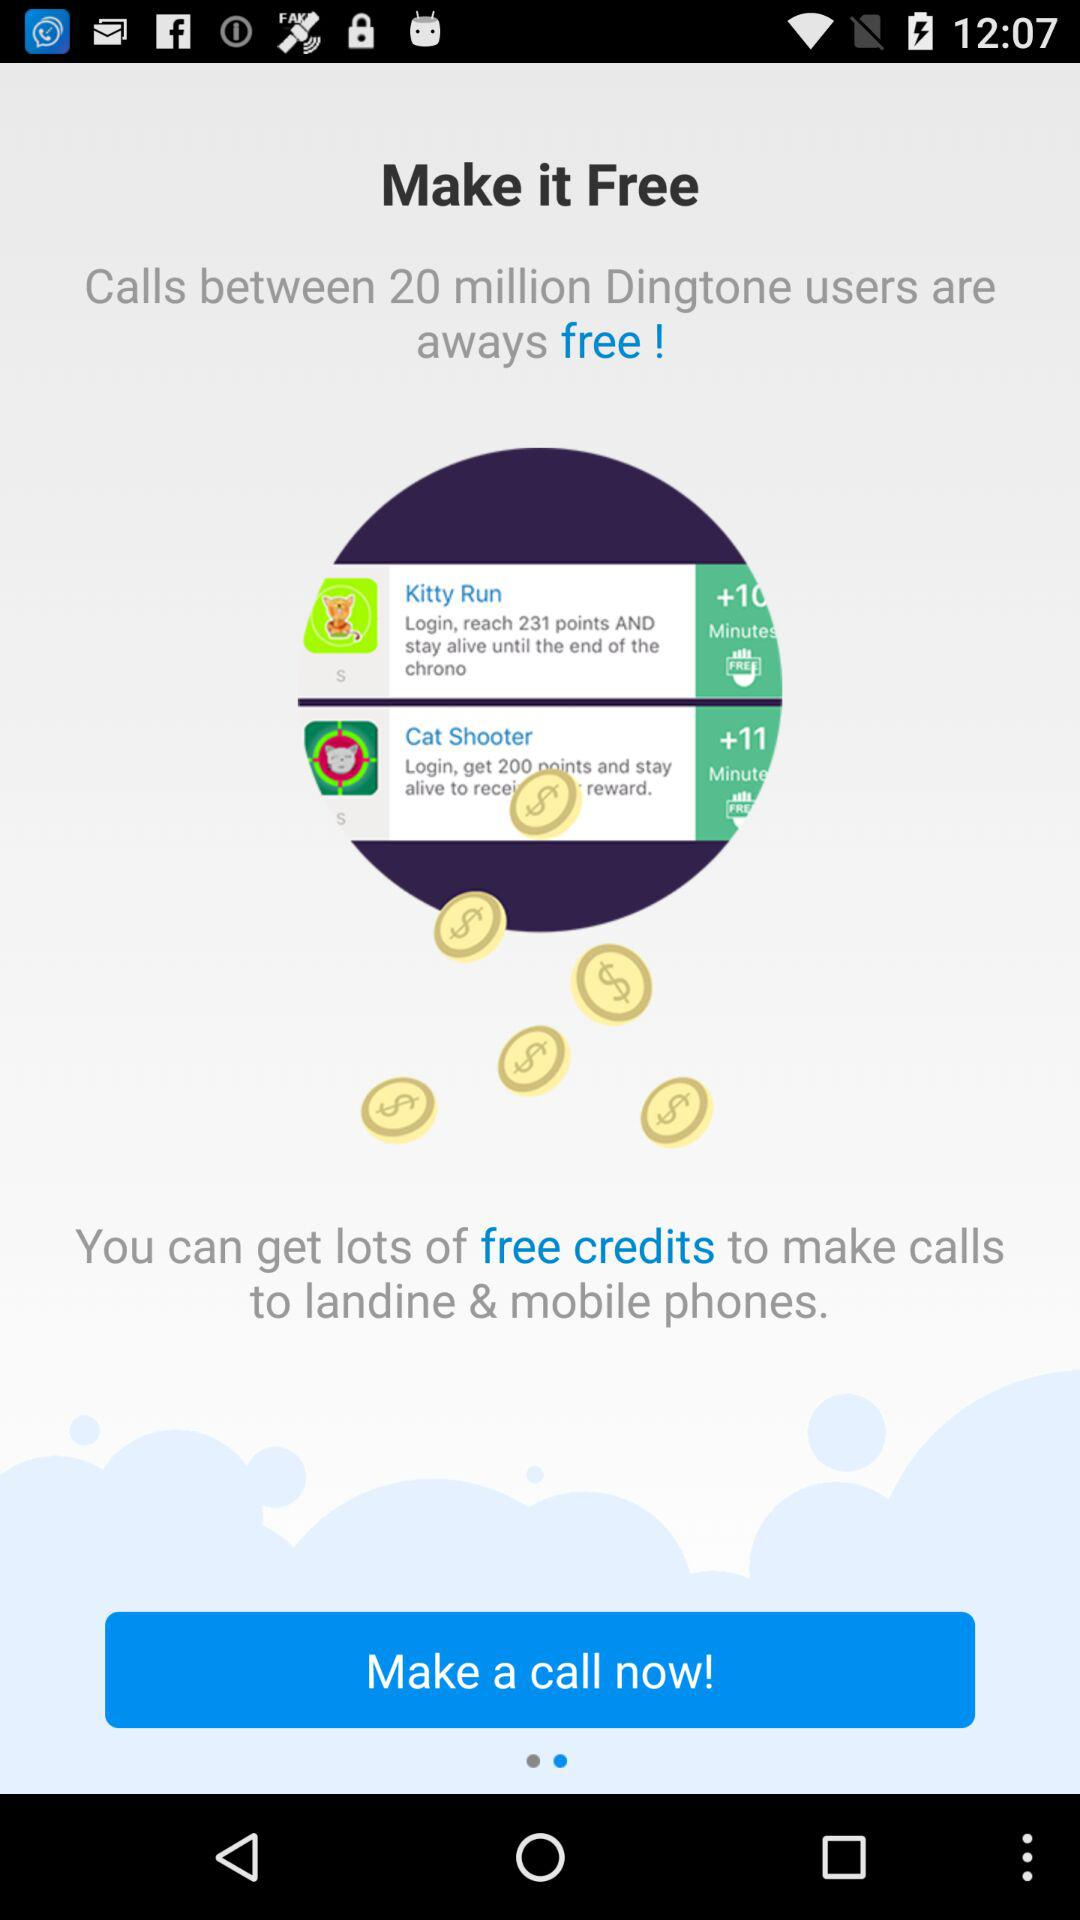Between how many "Dingtone" users are the calls free? The calls between the 20 million "Dingtone" users are free. 